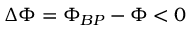<formula> <loc_0><loc_0><loc_500><loc_500>\Delta \Phi = \Phi _ { B P } - \Phi < 0</formula> 